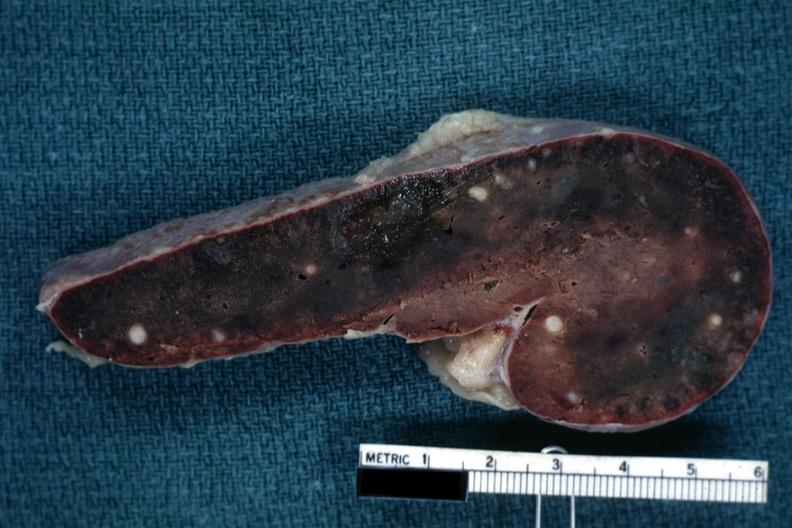s the unknown origin in mandible cut surface congested parenchyma with obvious granulomas?
Answer the question using a single word or phrase. No 